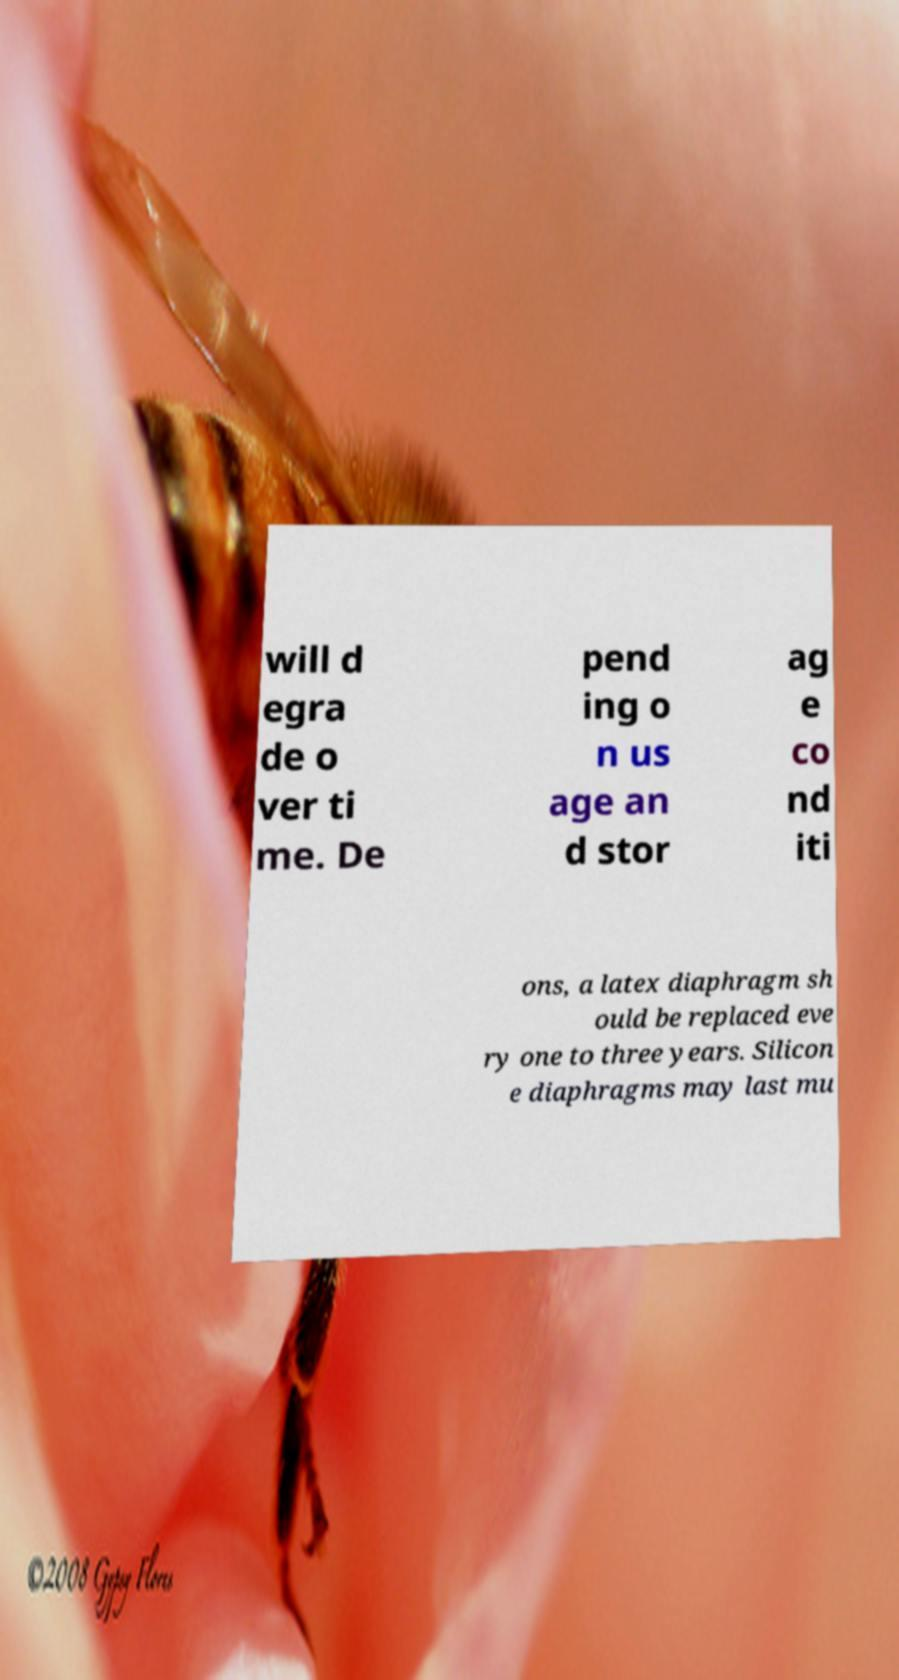Please read and relay the text visible in this image. What does it say? will d egra de o ver ti me. De pend ing o n us age an d stor ag e co nd iti ons, a latex diaphragm sh ould be replaced eve ry one to three years. Silicon e diaphragms may last mu 